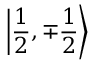<formula> <loc_0><loc_0><loc_500><loc_500>\left | { \frac { 1 } { 2 } } , \mp { \frac { 1 } { 2 } } \right \rangle</formula> 